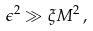Convert formula to latex. <formula><loc_0><loc_0><loc_500><loc_500>\epsilon ^ { 2 } \gg \xi M ^ { 2 } \, ,</formula> 